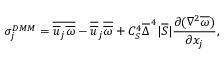Convert formula to latex. <formula><loc_0><loc_0><loc_500><loc_500>\sigma _ { j } ^ { D M M } = \overline { { \overline { u } _ { j } \overline { \omega } } } - \overline { { \overline { u } } } _ { j } \overline { { \overline { \omega } } } + C _ { S } ^ { 4 } \overline { \Delta } ^ { \, 4 } | \overline { S } | \frac { \partial ( \nabla ^ { 2 } \overline { \omega } ) } { \partial x _ { j } } ,</formula> 